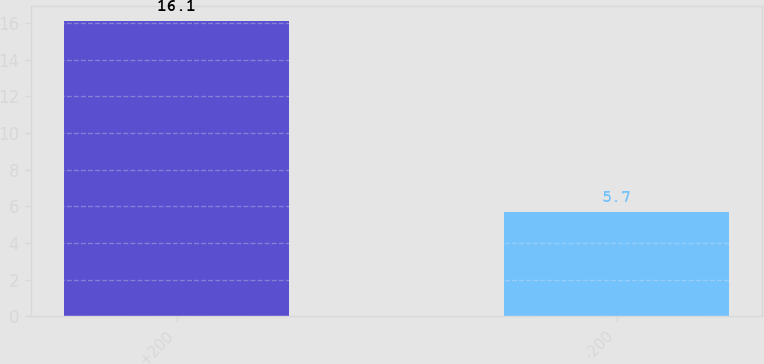Convert chart to OTSL. <chart><loc_0><loc_0><loc_500><loc_500><bar_chart><fcel>+200<fcel>-200<nl><fcel>16.1<fcel>5.7<nl></chart> 